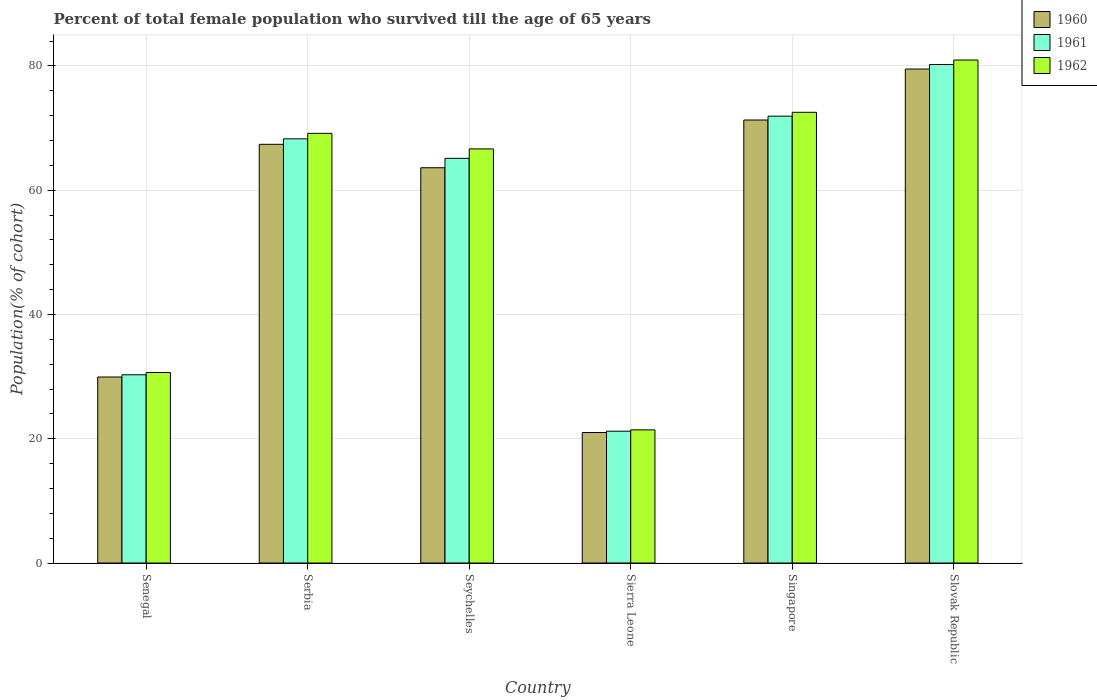How many groups of bars are there?
Your answer should be compact. 6. How many bars are there on the 5th tick from the right?
Your answer should be very brief. 3. What is the label of the 5th group of bars from the left?
Provide a succinct answer. Singapore. In how many cases, is the number of bars for a given country not equal to the number of legend labels?
Keep it short and to the point. 0. What is the percentage of total female population who survived till the age of 65 years in 1961 in Slovak Republic?
Offer a very short reply. 80.23. Across all countries, what is the maximum percentage of total female population who survived till the age of 65 years in 1961?
Provide a short and direct response. 80.23. Across all countries, what is the minimum percentage of total female population who survived till the age of 65 years in 1961?
Provide a succinct answer. 21.22. In which country was the percentage of total female population who survived till the age of 65 years in 1962 maximum?
Your answer should be compact. Slovak Republic. In which country was the percentage of total female population who survived till the age of 65 years in 1961 minimum?
Make the answer very short. Sierra Leone. What is the total percentage of total female population who survived till the age of 65 years in 1962 in the graph?
Make the answer very short. 341.39. What is the difference between the percentage of total female population who survived till the age of 65 years in 1960 in Serbia and that in Singapore?
Make the answer very short. -3.91. What is the difference between the percentage of total female population who survived till the age of 65 years in 1960 in Seychelles and the percentage of total female population who survived till the age of 65 years in 1962 in Sierra Leone?
Offer a terse response. 42.19. What is the average percentage of total female population who survived till the age of 65 years in 1962 per country?
Offer a very short reply. 56.9. What is the difference between the percentage of total female population who survived till the age of 65 years of/in 1961 and percentage of total female population who survived till the age of 65 years of/in 1960 in Serbia?
Give a very brief answer. 0.88. What is the ratio of the percentage of total female population who survived till the age of 65 years in 1962 in Seychelles to that in Sierra Leone?
Provide a short and direct response. 3.11. Is the difference between the percentage of total female population who survived till the age of 65 years in 1961 in Senegal and Singapore greater than the difference between the percentage of total female population who survived till the age of 65 years in 1960 in Senegal and Singapore?
Your answer should be very brief. No. What is the difference between the highest and the second highest percentage of total female population who survived till the age of 65 years in 1962?
Ensure brevity in your answer.  8.42. What is the difference between the highest and the lowest percentage of total female population who survived till the age of 65 years in 1960?
Your response must be concise. 58.5. In how many countries, is the percentage of total female population who survived till the age of 65 years in 1962 greater than the average percentage of total female population who survived till the age of 65 years in 1962 taken over all countries?
Your response must be concise. 4. What does the 3rd bar from the right in Sierra Leone represents?
Your answer should be very brief. 1960. How many bars are there?
Provide a succinct answer. 18. Are all the bars in the graph horizontal?
Offer a very short reply. No. How many countries are there in the graph?
Provide a short and direct response. 6. What is the difference between two consecutive major ticks on the Y-axis?
Provide a short and direct response. 20. Where does the legend appear in the graph?
Provide a succinct answer. Top right. What is the title of the graph?
Your response must be concise. Percent of total female population who survived till the age of 65 years. Does "1960" appear as one of the legend labels in the graph?
Your response must be concise. Yes. What is the label or title of the Y-axis?
Give a very brief answer. Population(% of cohort). What is the Population(% of cohort) in 1960 in Senegal?
Give a very brief answer. 29.94. What is the Population(% of cohort) in 1961 in Senegal?
Offer a terse response. 30.3. What is the Population(% of cohort) of 1962 in Senegal?
Ensure brevity in your answer.  30.66. What is the Population(% of cohort) in 1960 in Serbia?
Provide a succinct answer. 67.39. What is the Population(% of cohort) in 1961 in Serbia?
Give a very brief answer. 68.27. What is the Population(% of cohort) of 1962 in Serbia?
Provide a short and direct response. 69.15. What is the Population(% of cohort) of 1960 in Seychelles?
Give a very brief answer. 63.62. What is the Population(% of cohort) in 1961 in Seychelles?
Ensure brevity in your answer.  65.13. What is the Population(% of cohort) of 1962 in Seychelles?
Provide a short and direct response. 66.65. What is the Population(% of cohort) of 1960 in Sierra Leone?
Keep it short and to the point. 21. What is the Population(% of cohort) in 1961 in Sierra Leone?
Make the answer very short. 21.22. What is the Population(% of cohort) of 1962 in Sierra Leone?
Make the answer very short. 21.43. What is the Population(% of cohort) in 1960 in Singapore?
Your answer should be compact. 71.3. What is the Population(% of cohort) in 1961 in Singapore?
Your response must be concise. 71.92. What is the Population(% of cohort) in 1962 in Singapore?
Provide a succinct answer. 72.54. What is the Population(% of cohort) of 1960 in Slovak Republic?
Offer a very short reply. 79.51. What is the Population(% of cohort) of 1961 in Slovak Republic?
Provide a succinct answer. 80.23. What is the Population(% of cohort) in 1962 in Slovak Republic?
Your answer should be very brief. 80.95. Across all countries, what is the maximum Population(% of cohort) of 1960?
Make the answer very short. 79.51. Across all countries, what is the maximum Population(% of cohort) of 1961?
Keep it short and to the point. 80.23. Across all countries, what is the maximum Population(% of cohort) of 1962?
Give a very brief answer. 80.95. Across all countries, what is the minimum Population(% of cohort) in 1960?
Your answer should be compact. 21. Across all countries, what is the minimum Population(% of cohort) of 1961?
Offer a very short reply. 21.22. Across all countries, what is the minimum Population(% of cohort) in 1962?
Provide a short and direct response. 21.43. What is the total Population(% of cohort) in 1960 in the graph?
Offer a very short reply. 332.75. What is the total Population(% of cohort) in 1961 in the graph?
Offer a very short reply. 337.07. What is the total Population(% of cohort) of 1962 in the graph?
Your response must be concise. 341.39. What is the difference between the Population(% of cohort) of 1960 in Senegal and that in Serbia?
Your response must be concise. -37.45. What is the difference between the Population(% of cohort) in 1961 in Senegal and that in Serbia?
Give a very brief answer. -37.97. What is the difference between the Population(% of cohort) in 1962 in Senegal and that in Serbia?
Your answer should be compact. -38.5. What is the difference between the Population(% of cohort) of 1960 in Senegal and that in Seychelles?
Your answer should be very brief. -33.68. What is the difference between the Population(% of cohort) of 1961 in Senegal and that in Seychelles?
Offer a very short reply. -34.83. What is the difference between the Population(% of cohort) of 1962 in Senegal and that in Seychelles?
Your response must be concise. -35.99. What is the difference between the Population(% of cohort) of 1960 in Senegal and that in Sierra Leone?
Your answer should be very brief. 8.94. What is the difference between the Population(% of cohort) of 1961 in Senegal and that in Sierra Leone?
Your answer should be very brief. 9.08. What is the difference between the Population(% of cohort) of 1962 in Senegal and that in Sierra Leone?
Your answer should be compact. 9.23. What is the difference between the Population(% of cohort) of 1960 in Senegal and that in Singapore?
Provide a short and direct response. -41.36. What is the difference between the Population(% of cohort) in 1961 in Senegal and that in Singapore?
Ensure brevity in your answer.  -41.62. What is the difference between the Population(% of cohort) in 1962 in Senegal and that in Singapore?
Offer a terse response. -41.88. What is the difference between the Population(% of cohort) of 1960 in Senegal and that in Slovak Republic?
Your answer should be very brief. -49.57. What is the difference between the Population(% of cohort) in 1961 in Senegal and that in Slovak Republic?
Provide a succinct answer. -49.93. What is the difference between the Population(% of cohort) in 1962 in Senegal and that in Slovak Republic?
Your answer should be very brief. -50.29. What is the difference between the Population(% of cohort) in 1960 in Serbia and that in Seychelles?
Your response must be concise. 3.77. What is the difference between the Population(% of cohort) of 1961 in Serbia and that in Seychelles?
Your response must be concise. 3.14. What is the difference between the Population(% of cohort) in 1962 in Serbia and that in Seychelles?
Your response must be concise. 2.51. What is the difference between the Population(% of cohort) in 1960 in Serbia and that in Sierra Leone?
Make the answer very short. 46.39. What is the difference between the Population(% of cohort) of 1961 in Serbia and that in Sierra Leone?
Provide a succinct answer. 47.05. What is the difference between the Population(% of cohort) of 1962 in Serbia and that in Sierra Leone?
Your response must be concise. 47.72. What is the difference between the Population(% of cohort) of 1960 in Serbia and that in Singapore?
Your response must be concise. -3.91. What is the difference between the Population(% of cohort) in 1961 in Serbia and that in Singapore?
Give a very brief answer. -3.65. What is the difference between the Population(% of cohort) of 1962 in Serbia and that in Singapore?
Provide a succinct answer. -3.38. What is the difference between the Population(% of cohort) in 1960 in Serbia and that in Slovak Republic?
Ensure brevity in your answer.  -12.12. What is the difference between the Population(% of cohort) in 1961 in Serbia and that in Slovak Republic?
Offer a very short reply. -11.96. What is the difference between the Population(% of cohort) of 1962 in Serbia and that in Slovak Republic?
Provide a short and direct response. -11.8. What is the difference between the Population(% of cohort) in 1960 in Seychelles and that in Sierra Leone?
Offer a terse response. 42.61. What is the difference between the Population(% of cohort) in 1961 in Seychelles and that in Sierra Leone?
Your answer should be very brief. 43.92. What is the difference between the Population(% of cohort) in 1962 in Seychelles and that in Sierra Leone?
Provide a short and direct response. 45.22. What is the difference between the Population(% of cohort) in 1960 in Seychelles and that in Singapore?
Ensure brevity in your answer.  -7.68. What is the difference between the Population(% of cohort) of 1961 in Seychelles and that in Singapore?
Your answer should be very brief. -6.79. What is the difference between the Population(% of cohort) in 1962 in Seychelles and that in Singapore?
Offer a very short reply. -5.89. What is the difference between the Population(% of cohort) in 1960 in Seychelles and that in Slovak Republic?
Ensure brevity in your answer.  -15.89. What is the difference between the Population(% of cohort) of 1961 in Seychelles and that in Slovak Republic?
Offer a very short reply. -15.1. What is the difference between the Population(% of cohort) of 1962 in Seychelles and that in Slovak Republic?
Make the answer very short. -14.31. What is the difference between the Population(% of cohort) in 1960 in Sierra Leone and that in Singapore?
Offer a very short reply. -50.3. What is the difference between the Population(% of cohort) of 1961 in Sierra Leone and that in Singapore?
Ensure brevity in your answer.  -50.7. What is the difference between the Population(% of cohort) of 1962 in Sierra Leone and that in Singapore?
Offer a very short reply. -51.11. What is the difference between the Population(% of cohort) in 1960 in Sierra Leone and that in Slovak Republic?
Provide a succinct answer. -58.5. What is the difference between the Population(% of cohort) in 1961 in Sierra Leone and that in Slovak Republic?
Provide a succinct answer. -59.01. What is the difference between the Population(% of cohort) in 1962 in Sierra Leone and that in Slovak Republic?
Keep it short and to the point. -59.52. What is the difference between the Population(% of cohort) in 1960 in Singapore and that in Slovak Republic?
Keep it short and to the point. -8.2. What is the difference between the Population(% of cohort) in 1961 in Singapore and that in Slovak Republic?
Your answer should be very brief. -8.31. What is the difference between the Population(% of cohort) of 1962 in Singapore and that in Slovak Republic?
Offer a terse response. -8.42. What is the difference between the Population(% of cohort) in 1960 in Senegal and the Population(% of cohort) in 1961 in Serbia?
Give a very brief answer. -38.33. What is the difference between the Population(% of cohort) in 1960 in Senegal and the Population(% of cohort) in 1962 in Serbia?
Make the answer very short. -39.22. What is the difference between the Population(% of cohort) of 1961 in Senegal and the Population(% of cohort) of 1962 in Serbia?
Give a very brief answer. -38.86. What is the difference between the Population(% of cohort) of 1960 in Senegal and the Population(% of cohort) of 1961 in Seychelles?
Give a very brief answer. -35.19. What is the difference between the Population(% of cohort) in 1960 in Senegal and the Population(% of cohort) in 1962 in Seychelles?
Your answer should be compact. -36.71. What is the difference between the Population(% of cohort) in 1961 in Senegal and the Population(% of cohort) in 1962 in Seychelles?
Provide a succinct answer. -36.35. What is the difference between the Population(% of cohort) of 1960 in Senegal and the Population(% of cohort) of 1961 in Sierra Leone?
Make the answer very short. 8.72. What is the difference between the Population(% of cohort) of 1960 in Senegal and the Population(% of cohort) of 1962 in Sierra Leone?
Provide a short and direct response. 8.51. What is the difference between the Population(% of cohort) of 1961 in Senegal and the Population(% of cohort) of 1962 in Sierra Leone?
Keep it short and to the point. 8.87. What is the difference between the Population(% of cohort) of 1960 in Senegal and the Population(% of cohort) of 1961 in Singapore?
Give a very brief answer. -41.98. What is the difference between the Population(% of cohort) in 1960 in Senegal and the Population(% of cohort) in 1962 in Singapore?
Ensure brevity in your answer.  -42.6. What is the difference between the Population(% of cohort) of 1961 in Senegal and the Population(% of cohort) of 1962 in Singapore?
Your answer should be very brief. -42.24. What is the difference between the Population(% of cohort) in 1960 in Senegal and the Population(% of cohort) in 1961 in Slovak Republic?
Provide a short and direct response. -50.29. What is the difference between the Population(% of cohort) in 1960 in Senegal and the Population(% of cohort) in 1962 in Slovak Republic?
Your answer should be compact. -51.02. What is the difference between the Population(% of cohort) of 1961 in Senegal and the Population(% of cohort) of 1962 in Slovak Republic?
Offer a terse response. -50.66. What is the difference between the Population(% of cohort) in 1960 in Serbia and the Population(% of cohort) in 1961 in Seychelles?
Offer a very short reply. 2.26. What is the difference between the Population(% of cohort) in 1960 in Serbia and the Population(% of cohort) in 1962 in Seychelles?
Make the answer very short. 0.74. What is the difference between the Population(% of cohort) of 1961 in Serbia and the Population(% of cohort) of 1962 in Seychelles?
Your answer should be very brief. 1.62. What is the difference between the Population(% of cohort) in 1960 in Serbia and the Population(% of cohort) in 1961 in Sierra Leone?
Make the answer very short. 46.17. What is the difference between the Population(% of cohort) of 1960 in Serbia and the Population(% of cohort) of 1962 in Sierra Leone?
Make the answer very short. 45.96. What is the difference between the Population(% of cohort) of 1961 in Serbia and the Population(% of cohort) of 1962 in Sierra Leone?
Provide a short and direct response. 46.84. What is the difference between the Population(% of cohort) of 1960 in Serbia and the Population(% of cohort) of 1961 in Singapore?
Keep it short and to the point. -4.53. What is the difference between the Population(% of cohort) of 1960 in Serbia and the Population(% of cohort) of 1962 in Singapore?
Provide a succinct answer. -5.15. What is the difference between the Population(% of cohort) in 1961 in Serbia and the Population(% of cohort) in 1962 in Singapore?
Make the answer very short. -4.27. What is the difference between the Population(% of cohort) in 1960 in Serbia and the Population(% of cohort) in 1961 in Slovak Republic?
Keep it short and to the point. -12.84. What is the difference between the Population(% of cohort) in 1960 in Serbia and the Population(% of cohort) in 1962 in Slovak Republic?
Offer a very short reply. -13.57. What is the difference between the Population(% of cohort) of 1961 in Serbia and the Population(% of cohort) of 1962 in Slovak Republic?
Give a very brief answer. -12.68. What is the difference between the Population(% of cohort) in 1960 in Seychelles and the Population(% of cohort) in 1961 in Sierra Leone?
Provide a short and direct response. 42.4. What is the difference between the Population(% of cohort) in 1960 in Seychelles and the Population(% of cohort) in 1962 in Sierra Leone?
Your answer should be compact. 42.19. What is the difference between the Population(% of cohort) in 1961 in Seychelles and the Population(% of cohort) in 1962 in Sierra Leone?
Your answer should be very brief. 43.7. What is the difference between the Population(% of cohort) of 1960 in Seychelles and the Population(% of cohort) of 1961 in Singapore?
Ensure brevity in your answer.  -8.3. What is the difference between the Population(% of cohort) in 1960 in Seychelles and the Population(% of cohort) in 1962 in Singapore?
Make the answer very short. -8.92. What is the difference between the Population(% of cohort) of 1961 in Seychelles and the Population(% of cohort) of 1962 in Singapore?
Provide a succinct answer. -7.41. What is the difference between the Population(% of cohort) of 1960 in Seychelles and the Population(% of cohort) of 1961 in Slovak Republic?
Provide a short and direct response. -16.61. What is the difference between the Population(% of cohort) of 1960 in Seychelles and the Population(% of cohort) of 1962 in Slovak Republic?
Your answer should be very brief. -17.34. What is the difference between the Population(% of cohort) of 1961 in Seychelles and the Population(% of cohort) of 1962 in Slovak Republic?
Offer a terse response. -15.82. What is the difference between the Population(% of cohort) in 1960 in Sierra Leone and the Population(% of cohort) in 1961 in Singapore?
Provide a succinct answer. -50.92. What is the difference between the Population(% of cohort) in 1960 in Sierra Leone and the Population(% of cohort) in 1962 in Singapore?
Provide a succinct answer. -51.54. What is the difference between the Population(% of cohort) of 1961 in Sierra Leone and the Population(% of cohort) of 1962 in Singapore?
Provide a short and direct response. -51.32. What is the difference between the Population(% of cohort) in 1960 in Sierra Leone and the Population(% of cohort) in 1961 in Slovak Republic?
Your answer should be compact. -59.23. What is the difference between the Population(% of cohort) of 1960 in Sierra Leone and the Population(% of cohort) of 1962 in Slovak Republic?
Your response must be concise. -59.95. What is the difference between the Population(% of cohort) of 1961 in Sierra Leone and the Population(% of cohort) of 1962 in Slovak Republic?
Your answer should be very brief. -59.74. What is the difference between the Population(% of cohort) of 1960 in Singapore and the Population(% of cohort) of 1961 in Slovak Republic?
Keep it short and to the point. -8.93. What is the difference between the Population(% of cohort) of 1960 in Singapore and the Population(% of cohort) of 1962 in Slovak Republic?
Keep it short and to the point. -9.65. What is the difference between the Population(% of cohort) in 1961 in Singapore and the Population(% of cohort) in 1962 in Slovak Republic?
Offer a terse response. -9.03. What is the average Population(% of cohort) of 1960 per country?
Give a very brief answer. 55.46. What is the average Population(% of cohort) of 1961 per country?
Give a very brief answer. 56.18. What is the average Population(% of cohort) in 1962 per country?
Give a very brief answer. 56.9. What is the difference between the Population(% of cohort) of 1960 and Population(% of cohort) of 1961 in Senegal?
Give a very brief answer. -0.36. What is the difference between the Population(% of cohort) in 1960 and Population(% of cohort) in 1962 in Senegal?
Your answer should be compact. -0.72. What is the difference between the Population(% of cohort) in 1961 and Population(% of cohort) in 1962 in Senegal?
Ensure brevity in your answer.  -0.36. What is the difference between the Population(% of cohort) in 1960 and Population(% of cohort) in 1961 in Serbia?
Give a very brief answer. -0.88. What is the difference between the Population(% of cohort) in 1960 and Population(% of cohort) in 1962 in Serbia?
Your answer should be compact. -1.77. What is the difference between the Population(% of cohort) of 1961 and Population(% of cohort) of 1962 in Serbia?
Give a very brief answer. -0.88. What is the difference between the Population(% of cohort) of 1960 and Population(% of cohort) of 1961 in Seychelles?
Your response must be concise. -1.52. What is the difference between the Population(% of cohort) in 1960 and Population(% of cohort) in 1962 in Seychelles?
Your answer should be very brief. -3.03. What is the difference between the Population(% of cohort) of 1961 and Population(% of cohort) of 1962 in Seychelles?
Offer a very short reply. -1.52. What is the difference between the Population(% of cohort) of 1960 and Population(% of cohort) of 1961 in Sierra Leone?
Offer a very short reply. -0.21. What is the difference between the Population(% of cohort) in 1960 and Population(% of cohort) in 1962 in Sierra Leone?
Offer a terse response. -0.43. What is the difference between the Population(% of cohort) of 1961 and Population(% of cohort) of 1962 in Sierra Leone?
Give a very brief answer. -0.21. What is the difference between the Population(% of cohort) of 1960 and Population(% of cohort) of 1961 in Singapore?
Your response must be concise. -0.62. What is the difference between the Population(% of cohort) of 1960 and Population(% of cohort) of 1962 in Singapore?
Offer a terse response. -1.24. What is the difference between the Population(% of cohort) of 1961 and Population(% of cohort) of 1962 in Singapore?
Keep it short and to the point. -0.62. What is the difference between the Population(% of cohort) in 1960 and Population(% of cohort) in 1961 in Slovak Republic?
Give a very brief answer. -0.72. What is the difference between the Population(% of cohort) of 1960 and Population(% of cohort) of 1962 in Slovak Republic?
Your answer should be very brief. -1.45. What is the difference between the Population(% of cohort) in 1961 and Population(% of cohort) in 1962 in Slovak Republic?
Ensure brevity in your answer.  -0.72. What is the ratio of the Population(% of cohort) in 1960 in Senegal to that in Serbia?
Provide a succinct answer. 0.44. What is the ratio of the Population(% of cohort) in 1961 in Senegal to that in Serbia?
Offer a very short reply. 0.44. What is the ratio of the Population(% of cohort) in 1962 in Senegal to that in Serbia?
Ensure brevity in your answer.  0.44. What is the ratio of the Population(% of cohort) of 1960 in Senegal to that in Seychelles?
Offer a terse response. 0.47. What is the ratio of the Population(% of cohort) in 1961 in Senegal to that in Seychelles?
Ensure brevity in your answer.  0.47. What is the ratio of the Population(% of cohort) in 1962 in Senegal to that in Seychelles?
Offer a terse response. 0.46. What is the ratio of the Population(% of cohort) in 1960 in Senegal to that in Sierra Leone?
Your answer should be compact. 1.43. What is the ratio of the Population(% of cohort) of 1961 in Senegal to that in Sierra Leone?
Ensure brevity in your answer.  1.43. What is the ratio of the Population(% of cohort) of 1962 in Senegal to that in Sierra Leone?
Give a very brief answer. 1.43. What is the ratio of the Population(% of cohort) in 1960 in Senegal to that in Singapore?
Your answer should be compact. 0.42. What is the ratio of the Population(% of cohort) in 1961 in Senegal to that in Singapore?
Your answer should be very brief. 0.42. What is the ratio of the Population(% of cohort) of 1962 in Senegal to that in Singapore?
Your answer should be compact. 0.42. What is the ratio of the Population(% of cohort) in 1960 in Senegal to that in Slovak Republic?
Give a very brief answer. 0.38. What is the ratio of the Population(% of cohort) of 1961 in Senegal to that in Slovak Republic?
Your answer should be compact. 0.38. What is the ratio of the Population(% of cohort) in 1962 in Senegal to that in Slovak Republic?
Offer a very short reply. 0.38. What is the ratio of the Population(% of cohort) in 1960 in Serbia to that in Seychelles?
Make the answer very short. 1.06. What is the ratio of the Population(% of cohort) of 1961 in Serbia to that in Seychelles?
Offer a very short reply. 1.05. What is the ratio of the Population(% of cohort) of 1962 in Serbia to that in Seychelles?
Provide a succinct answer. 1.04. What is the ratio of the Population(% of cohort) in 1960 in Serbia to that in Sierra Leone?
Ensure brevity in your answer.  3.21. What is the ratio of the Population(% of cohort) in 1961 in Serbia to that in Sierra Leone?
Offer a terse response. 3.22. What is the ratio of the Population(% of cohort) of 1962 in Serbia to that in Sierra Leone?
Offer a terse response. 3.23. What is the ratio of the Population(% of cohort) of 1960 in Serbia to that in Singapore?
Make the answer very short. 0.95. What is the ratio of the Population(% of cohort) of 1961 in Serbia to that in Singapore?
Offer a very short reply. 0.95. What is the ratio of the Population(% of cohort) of 1962 in Serbia to that in Singapore?
Your answer should be very brief. 0.95. What is the ratio of the Population(% of cohort) in 1960 in Serbia to that in Slovak Republic?
Keep it short and to the point. 0.85. What is the ratio of the Population(% of cohort) of 1961 in Serbia to that in Slovak Republic?
Ensure brevity in your answer.  0.85. What is the ratio of the Population(% of cohort) in 1962 in Serbia to that in Slovak Republic?
Provide a succinct answer. 0.85. What is the ratio of the Population(% of cohort) in 1960 in Seychelles to that in Sierra Leone?
Provide a succinct answer. 3.03. What is the ratio of the Population(% of cohort) in 1961 in Seychelles to that in Sierra Leone?
Provide a succinct answer. 3.07. What is the ratio of the Population(% of cohort) of 1962 in Seychelles to that in Sierra Leone?
Offer a terse response. 3.11. What is the ratio of the Population(% of cohort) of 1960 in Seychelles to that in Singapore?
Ensure brevity in your answer.  0.89. What is the ratio of the Population(% of cohort) in 1961 in Seychelles to that in Singapore?
Provide a short and direct response. 0.91. What is the ratio of the Population(% of cohort) in 1962 in Seychelles to that in Singapore?
Your answer should be very brief. 0.92. What is the ratio of the Population(% of cohort) in 1960 in Seychelles to that in Slovak Republic?
Provide a short and direct response. 0.8. What is the ratio of the Population(% of cohort) of 1961 in Seychelles to that in Slovak Republic?
Make the answer very short. 0.81. What is the ratio of the Population(% of cohort) of 1962 in Seychelles to that in Slovak Republic?
Offer a terse response. 0.82. What is the ratio of the Population(% of cohort) in 1960 in Sierra Leone to that in Singapore?
Provide a short and direct response. 0.29. What is the ratio of the Population(% of cohort) of 1961 in Sierra Leone to that in Singapore?
Keep it short and to the point. 0.29. What is the ratio of the Population(% of cohort) of 1962 in Sierra Leone to that in Singapore?
Your answer should be very brief. 0.3. What is the ratio of the Population(% of cohort) in 1960 in Sierra Leone to that in Slovak Republic?
Make the answer very short. 0.26. What is the ratio of the Population(% of cohort) in 1961 in Sierra Leone to that in Slovak Republic?
Give a very brief answer. 0.26. What is the ratio of the Population(% of cohort) in 1962 in Sierra Leone to that in Slovak Republic?
Offer a terse response. 0.26. What is the ratio of the Population(% of cohort) of 1960 in Singapore to that in Slovak Republic?
Provide a short and direct response. 0.9. What is the ratio of the Population(% of cohort) in 1961 in Singapore to that in Slovak Republic?
Provide a succinct answer. 0.9. What is the ratio of the Population(% of cohort) of 1962 in Singapore to that in Slovak Republic?
Give a very brief answer. 0.9. What is the difference between the highest and the second highest Population(% of cohort) of 1960?
Provide a short and direct response. 8.2. What is the difference between the highest and the second highest Population(% of cohort) in 1961?
Your response must be concise. 8.31. What is the difference between the highest and the second highest Population(% of cohort) of 1962?
Provide a short and direct response. 8.42. What is the difference between the highest and the lowest Population(% of cohort) of 1960?
Make the answer very short. 58.5. What is the difference between the highest and the lowest Population(% of cohort) in 1961?
Your response must be concise. 59.01. What is the difference between the highest and the lowest Population(% of cohort) of 1962?
Your response must be concise. 59.52. 